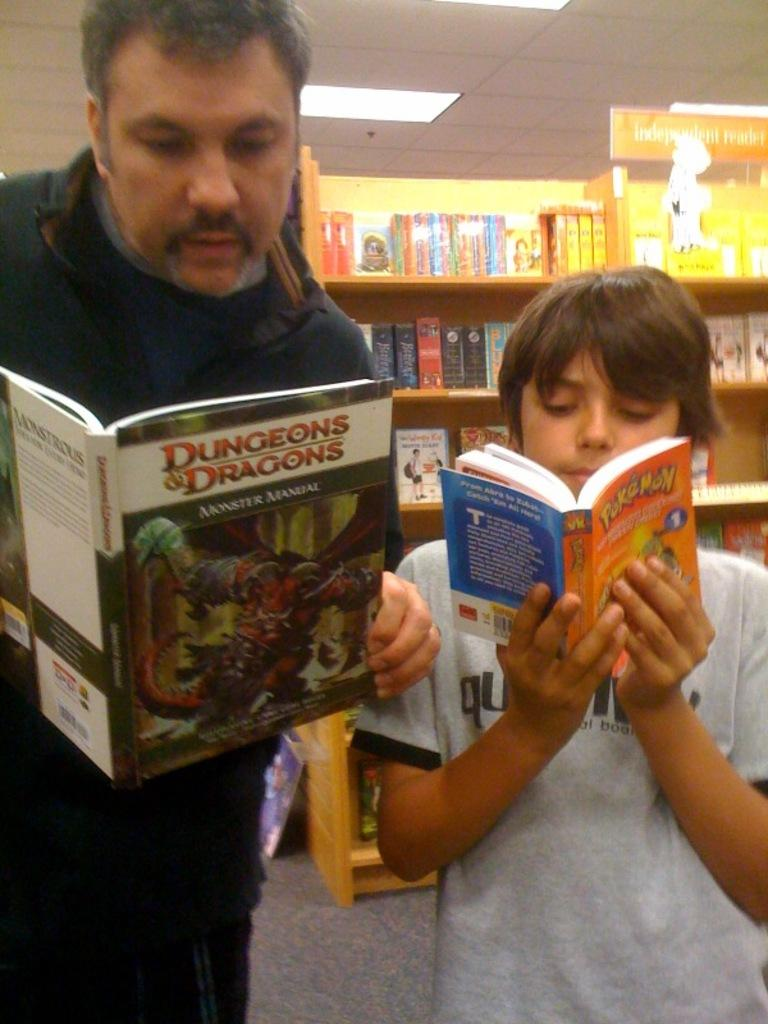<image>
Create a compact narrative representing the image presented. A man is reading a dungeons and dragons book and a child is reading a pokemon book. 